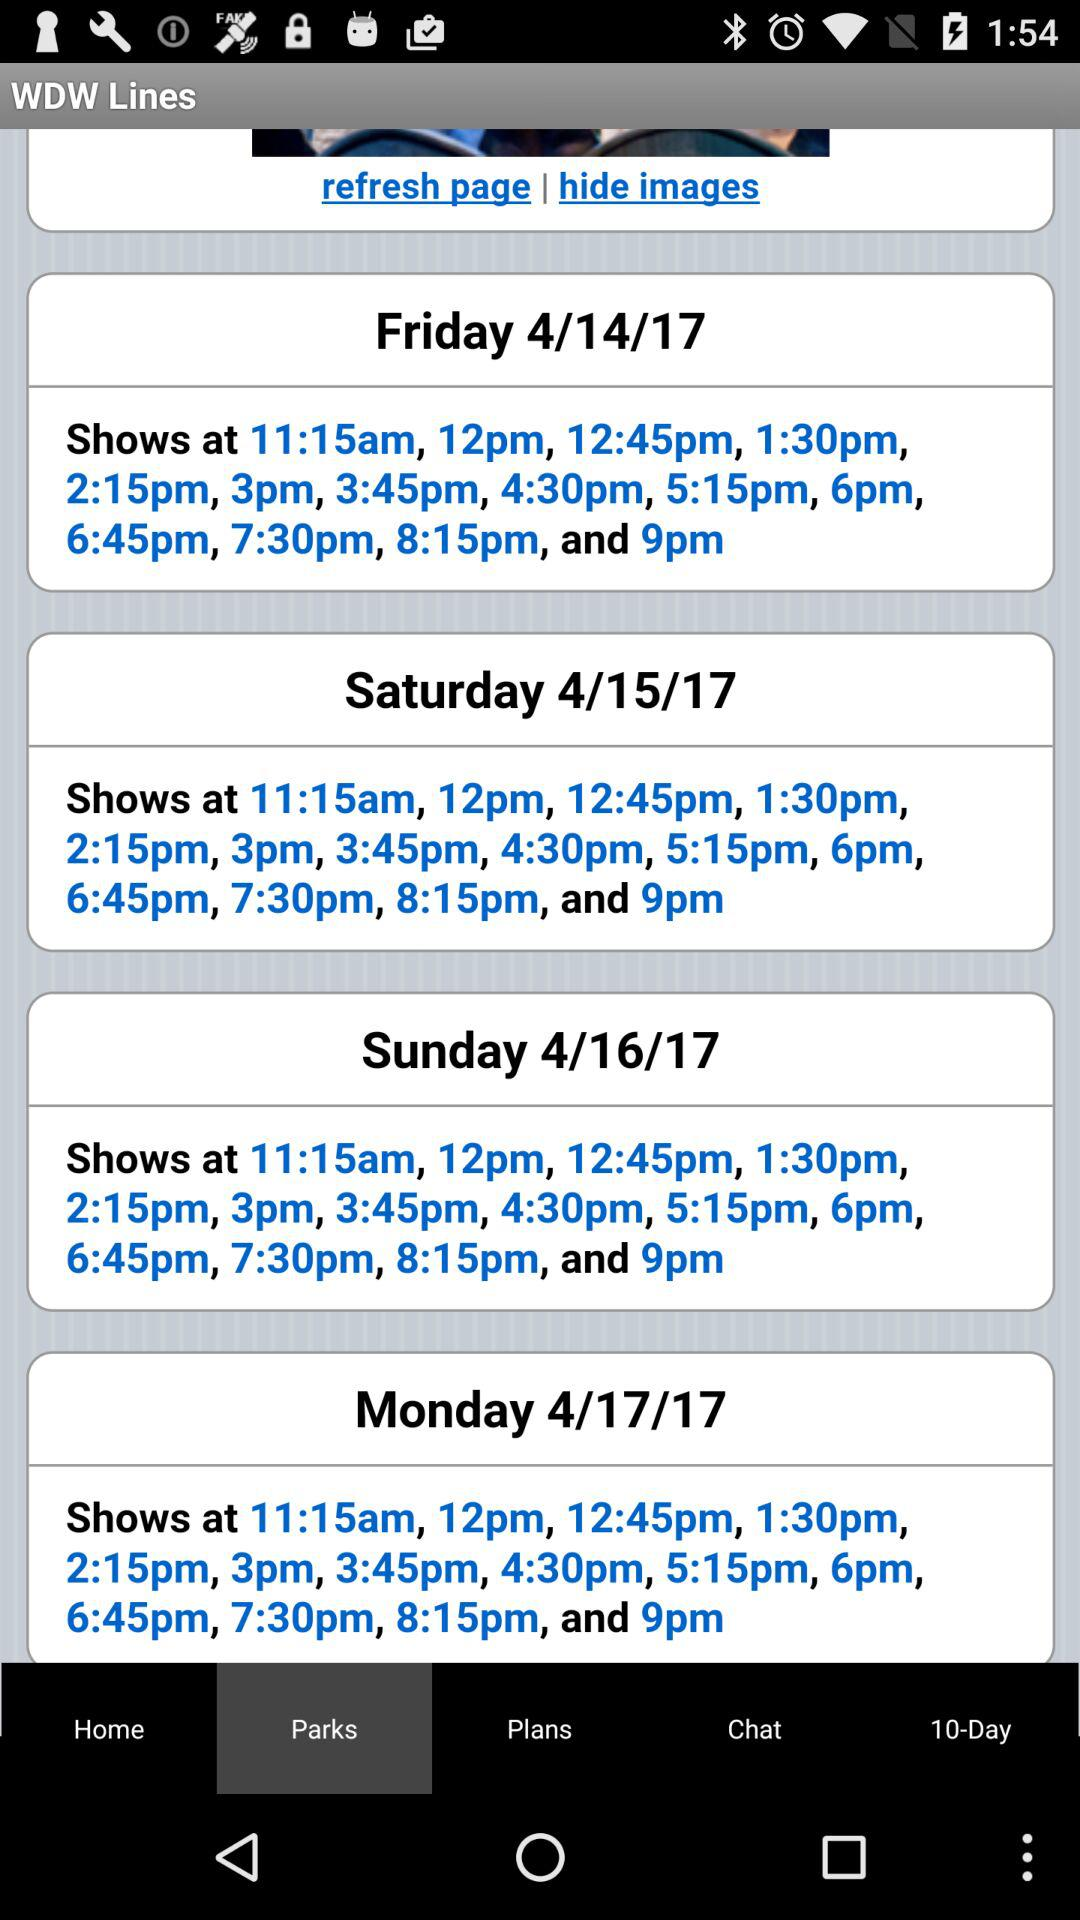What is the date on Friday? The date on Friday is April 14, 2017. 